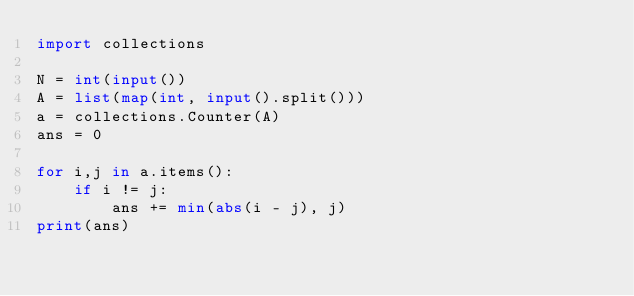<code> <loc_0><loc_0><loc_500><loc_500><_Python_>import collections

N = int(input())
A = list(map(int, input().split()))
a = collections.Counter(A)
ans = 0

for i,j in a.items():
    if i != j:
        ans += min(abs(i - j), j)
print(ans)</code> 